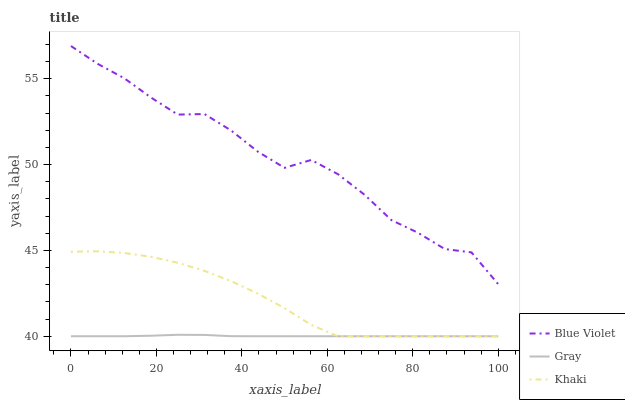Does Gray have the minimum area under the curve?
Answer yes or no. Yes. Does Blue Violet have the maximum area under the curve?
Answer yes or no. Yes. Does Khaki have the minimum area under the curve?
Answer yes or no. No. Does Khaki have the maximum area under the curve?
Answer yes or no. No. Is Gray the smoothest?
Answer yes or no. Yes. Is Blue Violet the roughest?
Answer yes or no. Yes. Is Khaki the smoothest?
Answer yes or no. No. Is Khaki the roughest?
Answer yes or no. No. Does Gray have the lowest value?
Answer yes or no. Yes. Does Blue Violet have the lowest value?
Answer yes or no. No. Does Blue Violet have the highest value?
Answer yes or no. Yes. Does Khaki have the highest value?
Answer yes or no. No. Is Khaki less than Blue Violet?
Answer yes or no. Yes. Is Blue Violet greater than Khaki?
Answer yes or no. Yes. Does Khaki intersect Gray?
Answer yes or no. Yes. Is Khaki less than Gray?
Answer yes or no. No. Is Khaki greater than Gray?
Answer yes or no. No. Does Khaki intersect Blue Violet?
Answer yes or no. No. 